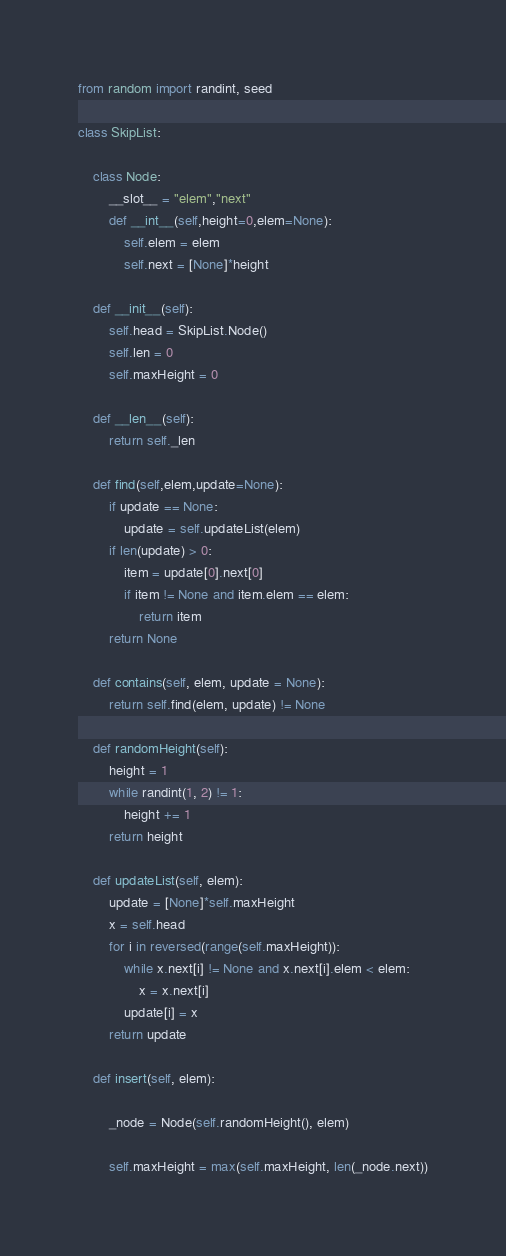Convert code to text. <code><loc_0><loc_0><loc_500><loc_500><_Python_>from random import randint, seed

class SkipList:
    
    class Node:
        __slot__ = "elem","next"
        def __int__(self,height=0,elem=None):
            self.elem = elem
            self.next = [None]*height

    def __init__(self):
        self.head = SkipList.Node()
        self.len = 0
        self.maxHeight = 0

    def __len__(self):
        return self._len

    def find(self,elem,update=None):
        if update == None:
            update = self.updateList(elem)
        if len(update) > 0:
            item = update[0].next[0]
            if item != None and item.elem == elem:
                return item
        return None

    def contains(self, elem, update = None):
        return self.find(elem, update) != None

    def randomHeight(self):
        height = 1
        while randint(1, 2) != 1:
            height += 1
        return height

    def updateList(self, elem):
        update = [None]*self.maxHeight
        x = self.head
        for i in reversed(range(self.maxHeight)):
            while x.next[i] != None and x.next[i].elem < elem:
                x = x.next[i]
            update[i] = x
        return update
        
    def insert(self, elem):

        _node = Node(self.randomHeight(), elem)

        self.maxHeight = max(self.maxHeight, len(_node.next))</code> 